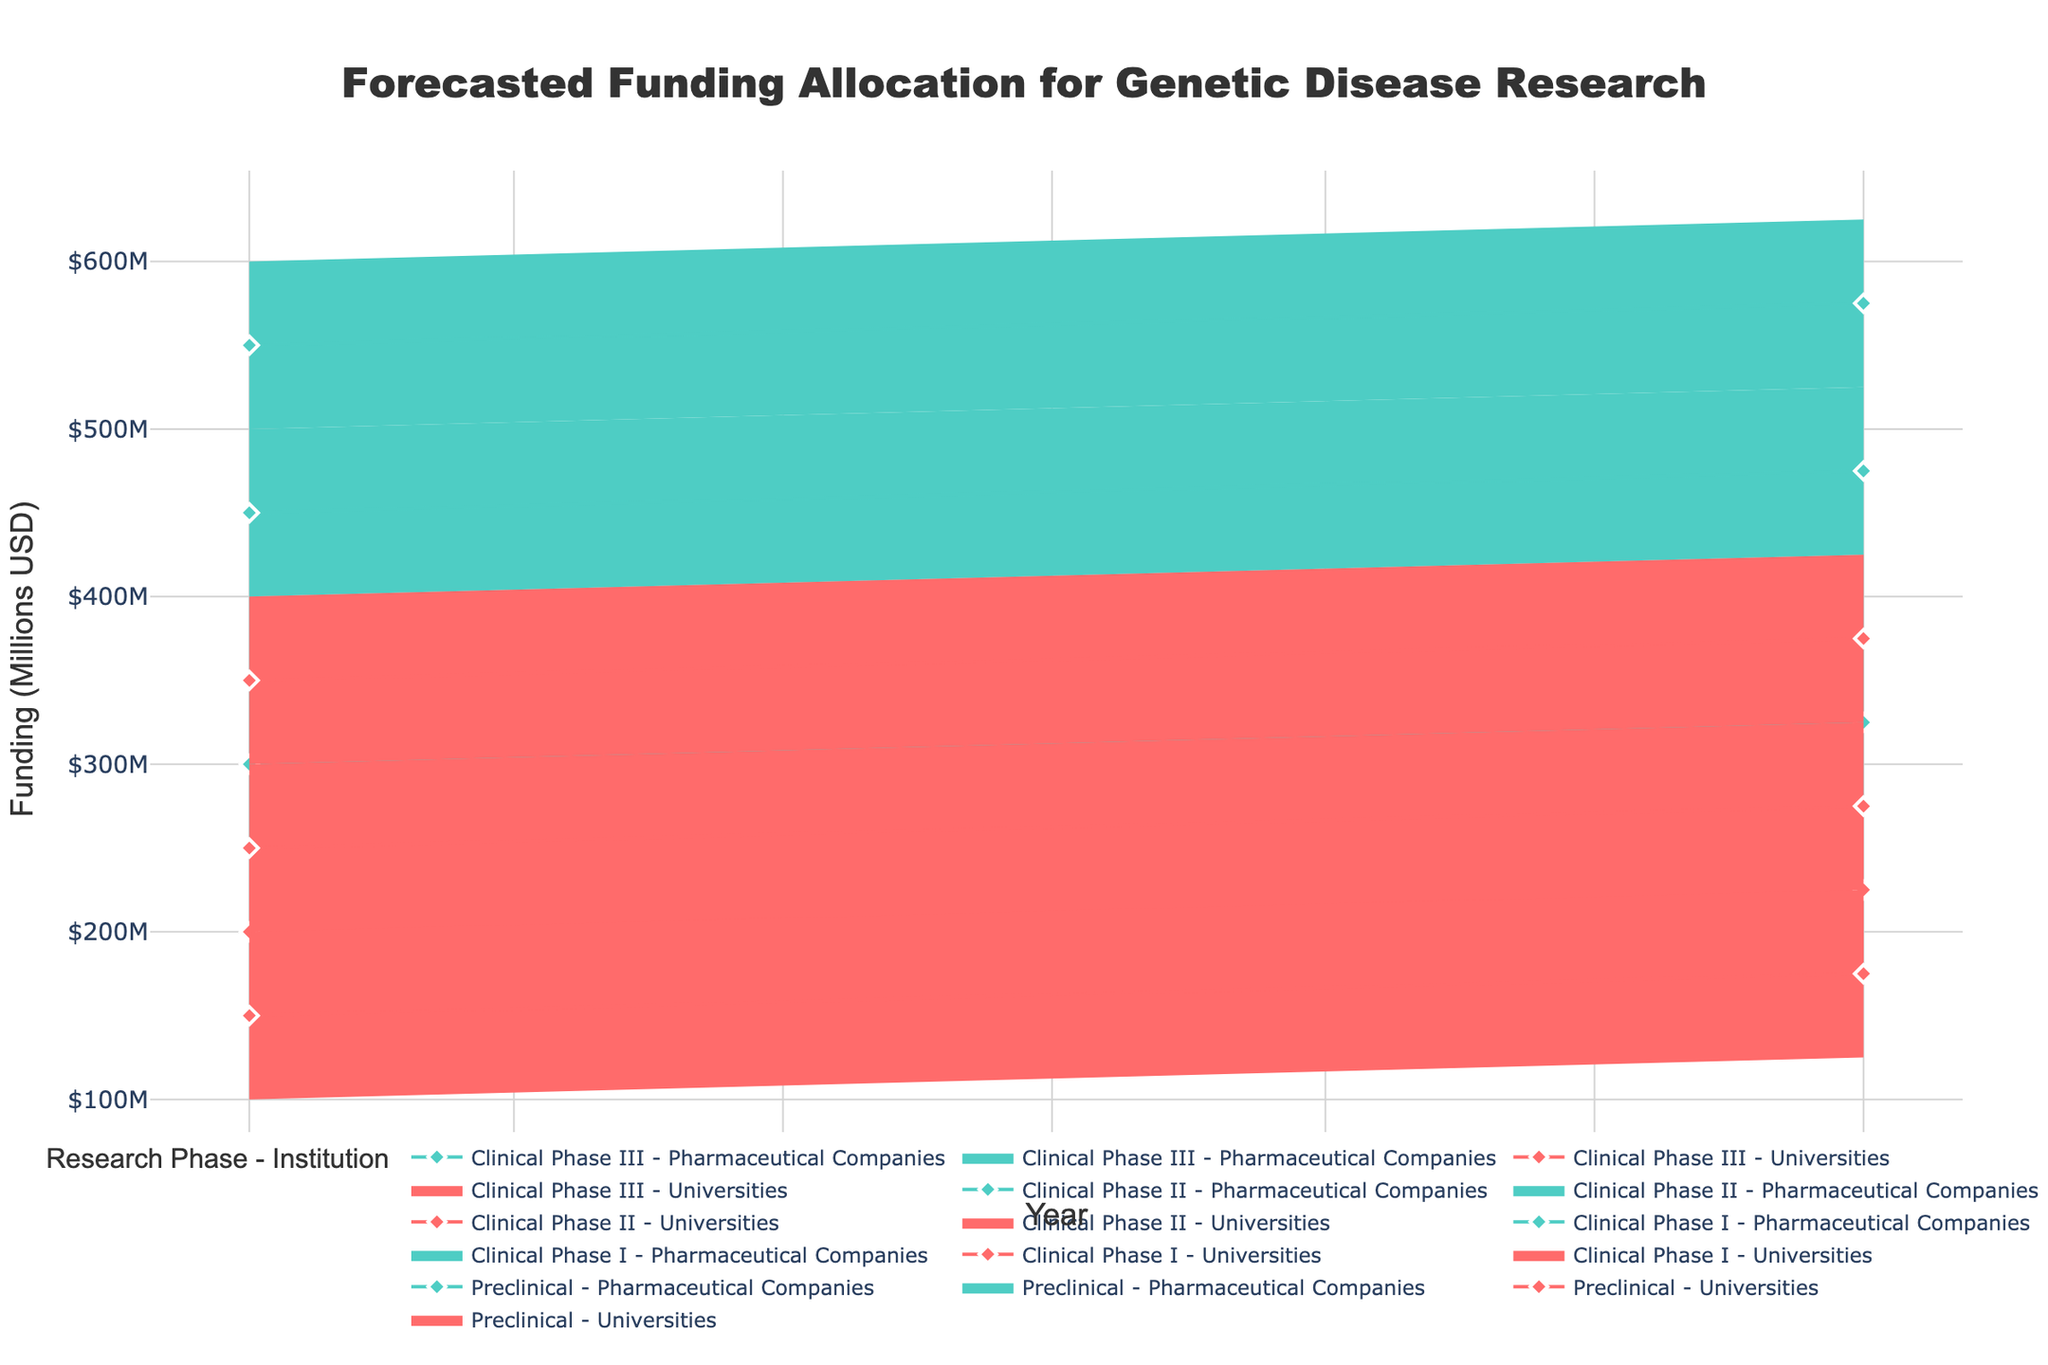What's the title of the figure? The title of the figure is displayed prominently at the top. It reads "Forecasted Funding Allocation for Genetic Disease Research".
Answer: Forecasted Funding Allocation for Genetic Disease Research What is the forecasted funding range for Clinical Phase I by universities in 2025? The forecasted funding range is indicated by the low and high estimates for Clinical Phase I by universities in 2025. On the plot, these are the lower and upper boundaries of the shaded region for this category. The range is from $125M (low estimate) to $225M (high estimate).
Answer: $125M to $225M In 2024, which institution type receives higher median funding in Clinical Phase III, and by how much? In 2024, Clinical Phase III funding for universities has a mid estimate of $350M. For pharmaceutical companies, the mid estimate is $550M. Comparing these values, pharmaceutical companies receive higher median funding by $550M - $350M = $200M.
Answer: Pharmaceutical companies; $200M What trend do you observe in the funding allocation for preclinical research by universities from 2024 to 2025? Observing the lines for preclinical research by universities from 2024 to 2025, the mid estimates increase from $200M in 2024 to $225M in 2025, indicating an upward trend.
Answer: Increasing trend What is the color used to represent pharmaceutical companies in the plot? The color used to represent pharmaceutical companies in the plot is a distinct shade of teal-like color, as specified in the code details.
Answer: Teal Which research phase receives the highest median forecasted funding in 2025 by pharmaceutical companies and what is the amount? Examining the mid estimate lines for pharmaceutical companies in 2025 across all research phases, Clinical Phase III has the highest value at $575M. This can be derived by looking at the diamond markers.
Answer: Clinical Phase III; $575M How does the forecasted funding for Clinical Phase II by pharmaceutical companies in 2024 compare to Clinical Phase III by the same institution? In 2024, Clinical Phase II by pharmaceutical companies has a mid estimate of $450M, while Clinical Phase III has a mid estimate of $550M. Thus, Clinical Phase III receives $550M - $450M = $100M more funding.
Answer: Clinical Phase III receives $100M more For which year does the forecast show a more significant increase in funding for preclinical research by pharmaceutical companies, and how much is the increase? From 2024 to 2025, preclinical research funding by pharmaceutical companies increases from a mid estimate of $350M in 2024 to $375M in 2025. The increase is $375M - $350M = $25M.
Answer: 2025; $25M What is the forecasted funding for Clinical Phase I by pharmaceutical companies in 2024, and how does it compare to the funding by universities for the same phase and year? In 2024, the mid estimate for Clinical Phase I by pharmaceutical companies is $300M, while for universities, it is $150M. Therefore, pharmaceutical companies receive $300M - $150M = $150M more funding compared to universities.
Answer: Pharmaceutical companies receive $150M more 